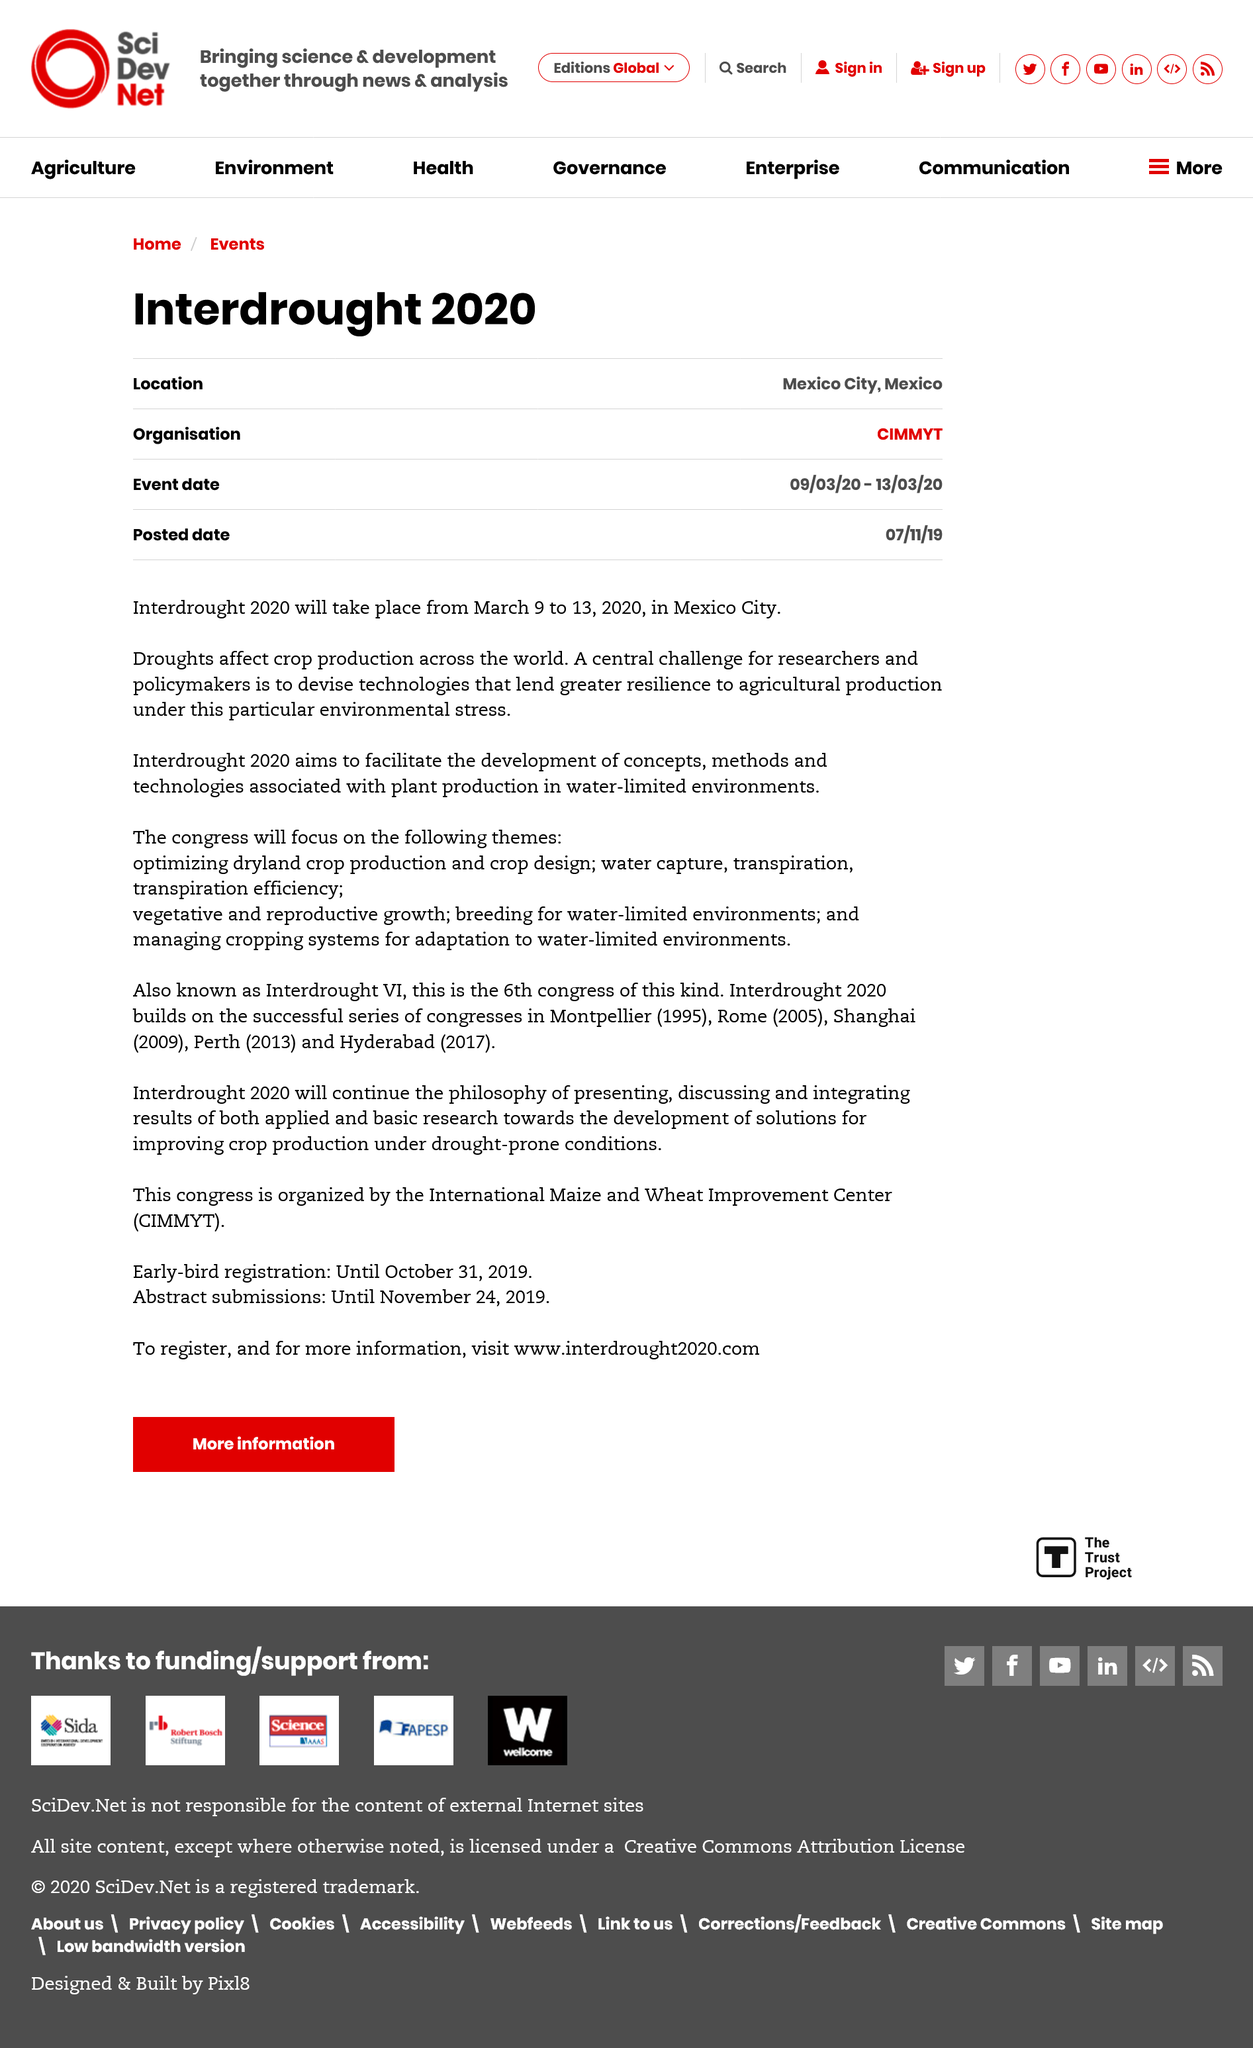List a handful of essential elements in this visual. The organization for Interdrought 2020 is the International Maize and Wheat Improvement Center (CIMMYT). Droughts significantly impact crop production across the world, as they can lead to reduced water availability, soil moisture depletion, and decreased plant growth and yield. It has been announced that Interdrought 2020 will be held in Mexico City. 